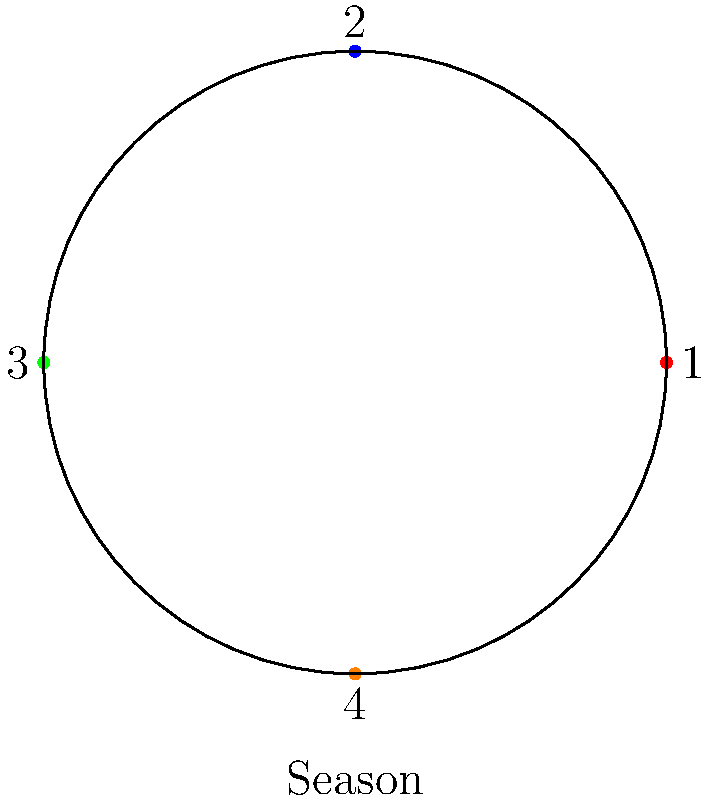Consider a reality TV show that airs four seasons each year, represented by the cyclic group $C_4$. If the current season is represented by element 2 in the group, what element will represent the season that airs 7 seasons from now? Let's approach this step-by-step:

1) The cyclic group $C_4$ represents the four seasons of the show, with elements {1, 2, 3, 4}.

2) The current season is represented by element 2.

3) We need to find the season 7 seasons from now. This means we need to apply the group operation 7 times.

4) In a cyclic group, the operation is essentially addition modulo the group order. Here, it's addition modulo 4.

5) We can express this mathematically as: $(2 + 7) \bmod 4$

6) $2 + 7 = 9$

7) $9 \bmod 4 = 1$, because $9 = 2 \times 4 + 1$

8) Therefore, 7 seasons from the current season (represented by 2) will be represented by element 1 in the group.

This result shows how the cyclic nature of the group represents the recurring schedule of the TV show seasons.
Answer: 1 